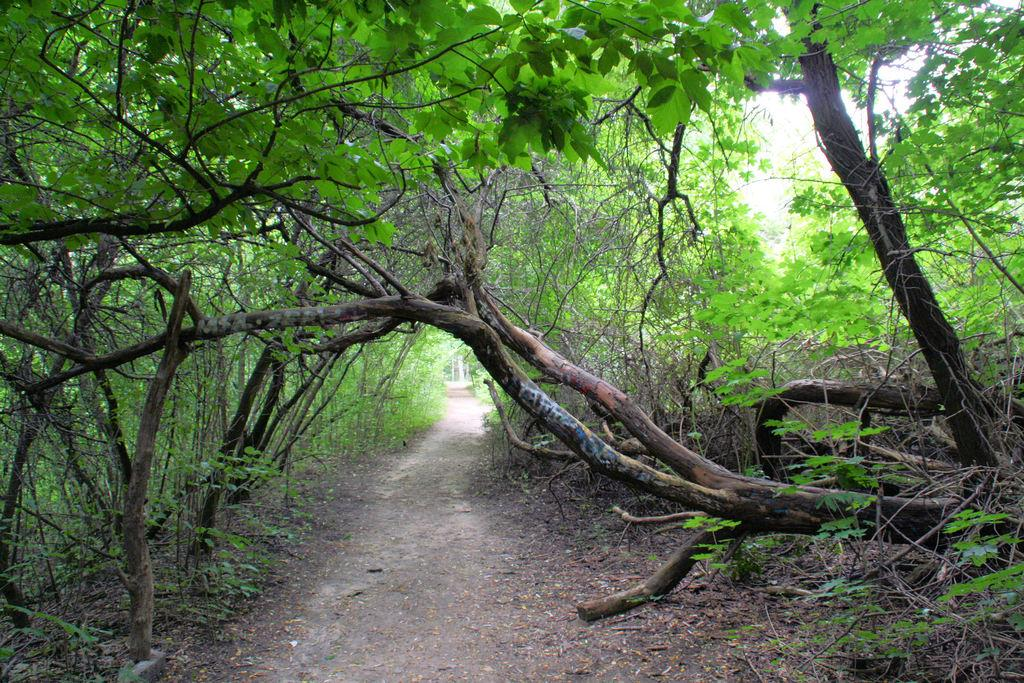What type of vegetation can be seen in the image? There are plants and trees in the image. Can you describe the plants and trees in the image? The image shows plants and trees, but specific details about their types or characteristics are not provided. What type of vegetable is being used to express anger in the image? There is no vegetable present in the image, and no expression of anger can be observed. 